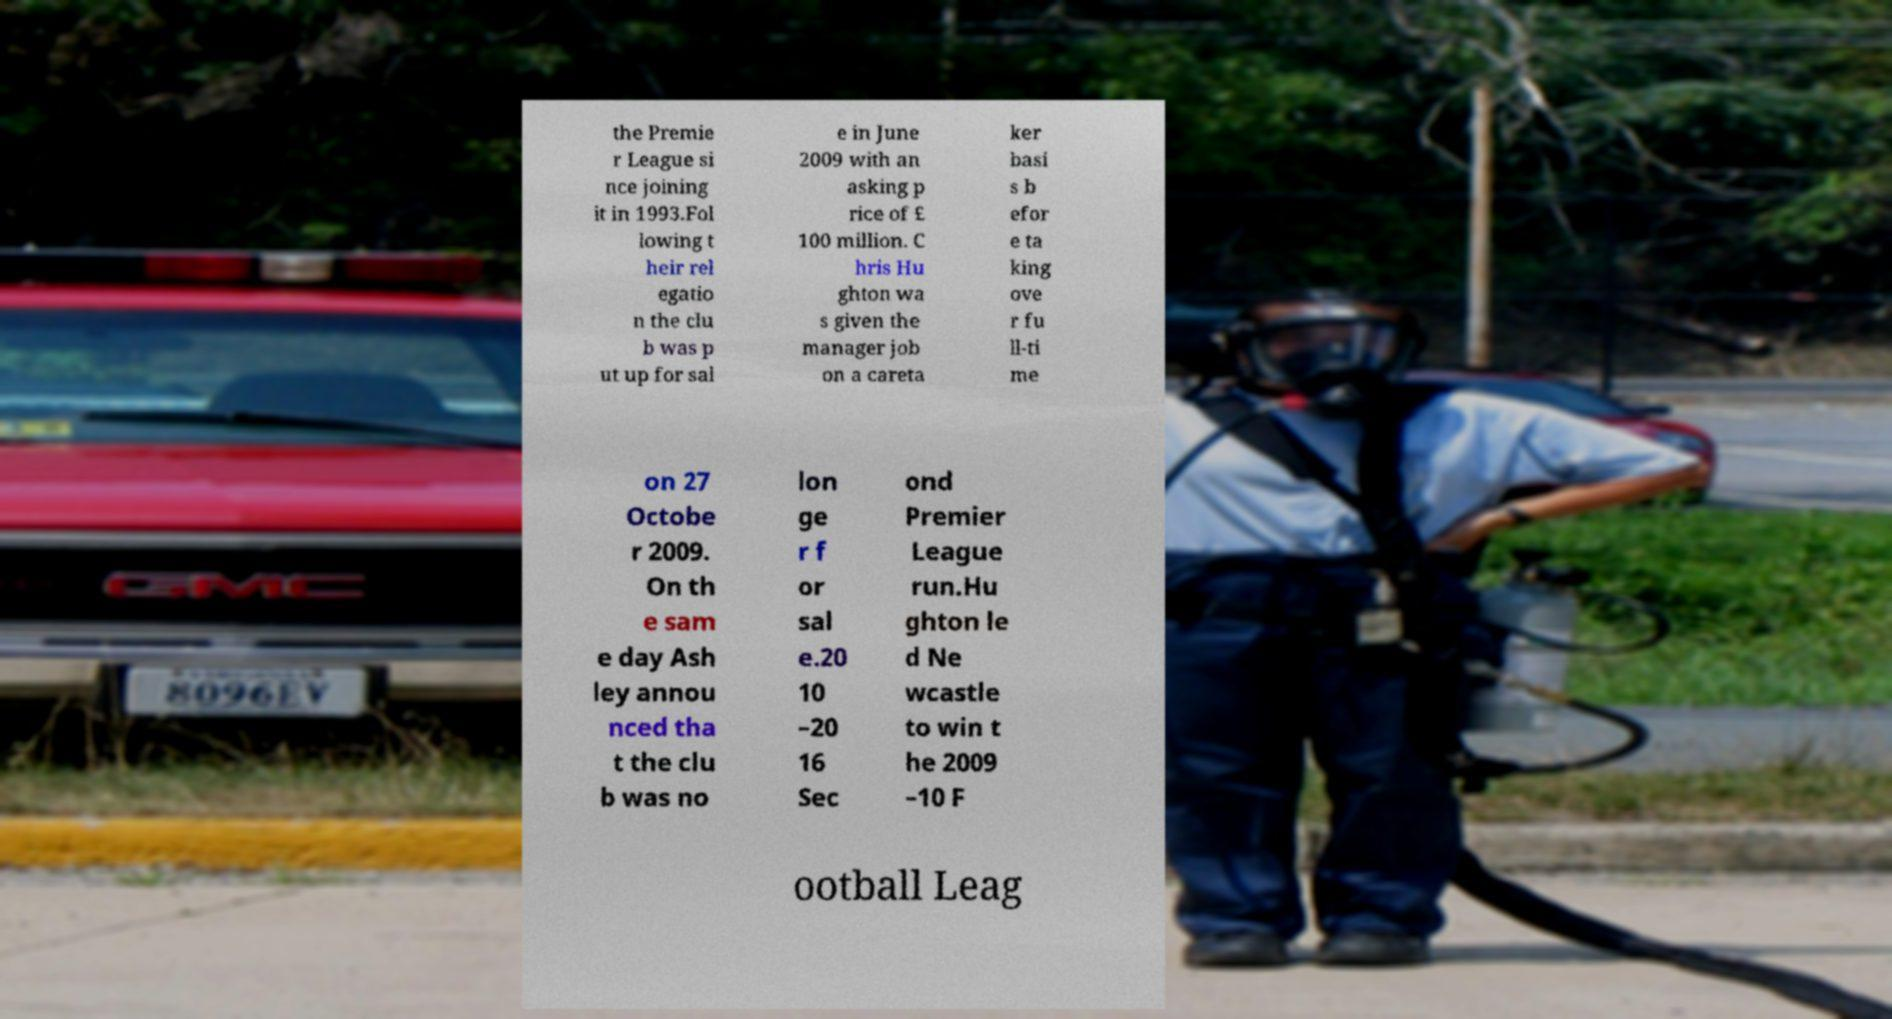I need the written content from this picture converted into text. Can you do that? the Premie r League si nce joining it in 1993.Fol lowing t heir rel egatio n the clu b was p ut up for sal e in June 2009 with an asking p rice of £ 100 million. C hris Hu ghton wa s given the manager job on a careta ker basi s b efor e ta king ove r fu ll-ti me on 27 Octobe r 2009. On th e sam e day Ash ley annou nced tha t the clu b was no lon ge r f or sal e.20 10 –20 16 Sec ond Premier League run.Hu ghton le d Ne wcastle to win t he 2009 –10 F ootball Leag 